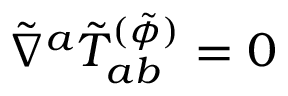<formula> <loc_0><loc_0><loc_500><loc_500>\tilde { \nabla } ^ { a } \tilde { T } _ { a b } ^ { ( \tilde { \phi } ) } = 0</formula> 